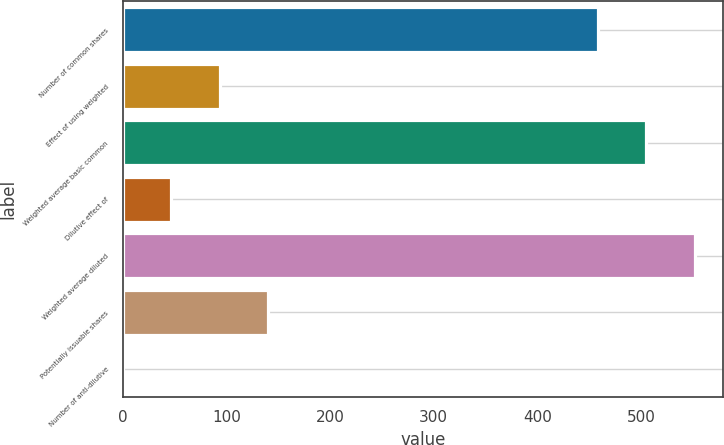Convert chart. <chart><loc_0><loc_0><loc_500><loc_500><bar_chart><fcel>Number of common shares<fcel>Effect of using weighted<fcel>Weighted average basic common<fcel>Dilutive effect of<fcel>Weighted average diluted<fcel>Potentially issuable shares<fcel>Number of anti-dilutive<nl><fcel>458.5<fcel>93.44<fcel>505.02<fcel>46.92<fcel>551.54<fcel>139.96<fcel>0.4<nl></chart> 